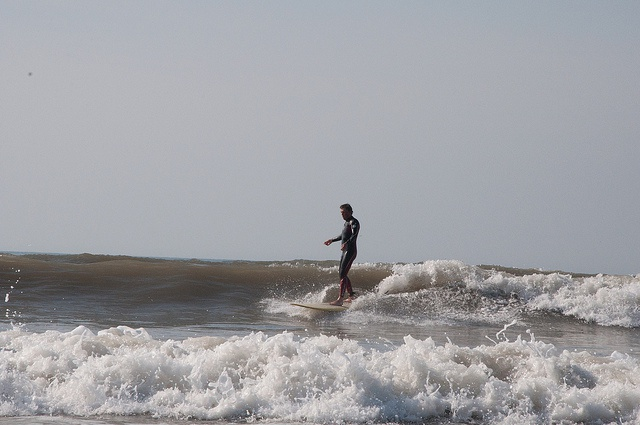Describe the objects in this image and their specific colors. I can see people in darkgray, black, and gray tones and surfboard in darkgray and gray tones in this image. 